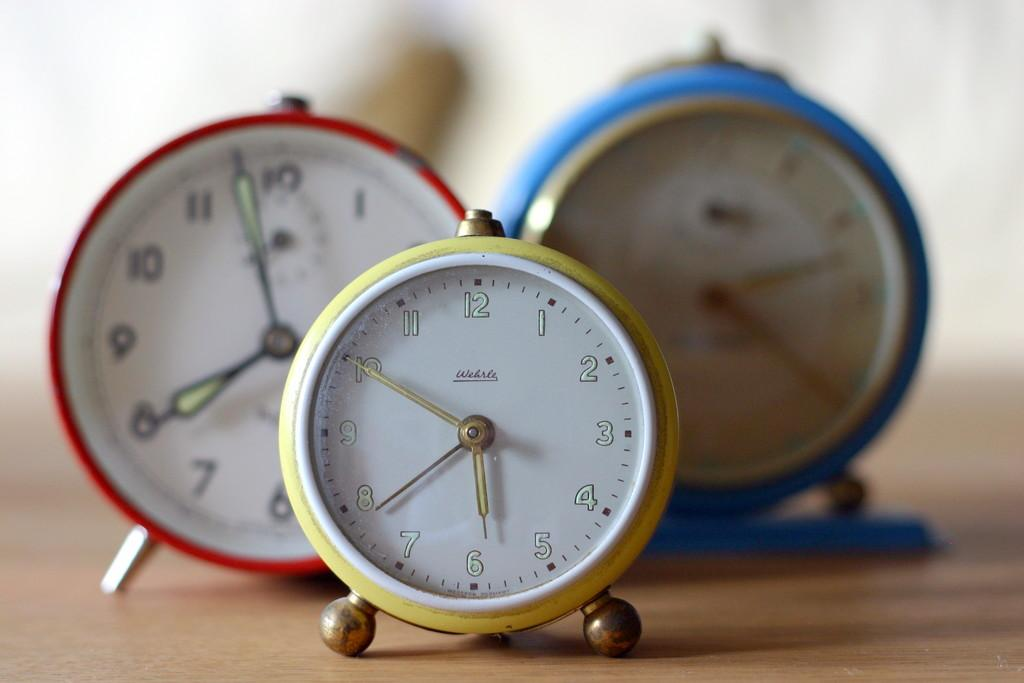<image>
Render a clear and concise summary of the photo. Three clocks of varying sizes, the smallest reading 5:50 